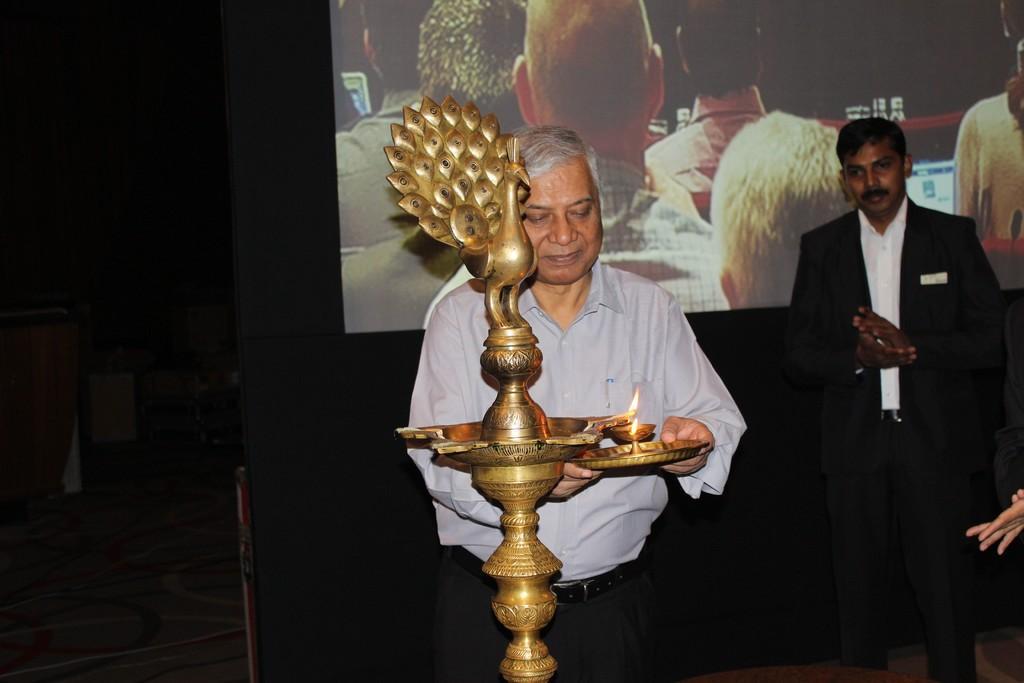In one or two sentences, can you explain what this image depicts? In this image there are people. The man standing in the center is holding a plate and there is a lamp. In the background there is a screen. 